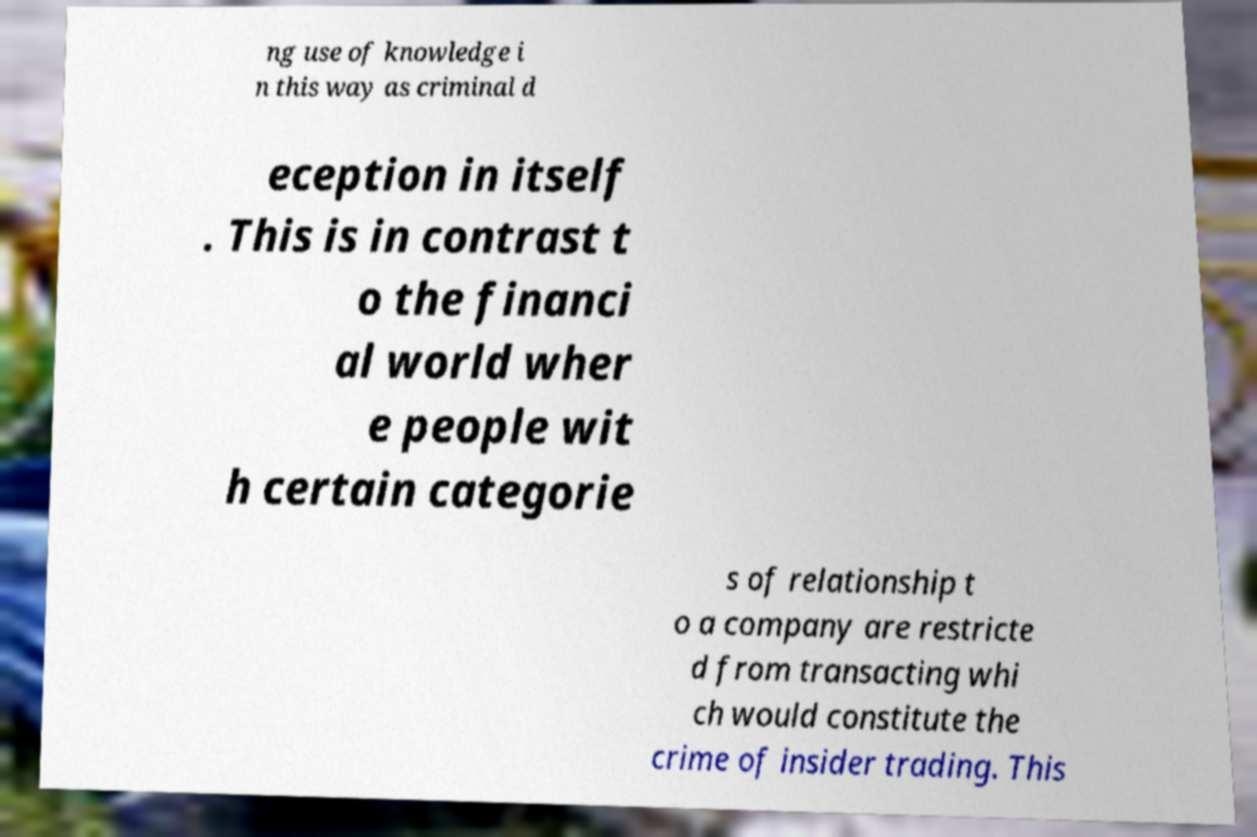For documentation purposes, I need the text within this image transcribed. Could you provide that? ng use of knowledge i n this way as criminal d eception in itself . This is in contrast t o the financi al world wher e people wit h certain categorie s of relationship t o a company are restricte d from transacting whi ch would constitute the crime of insider trading. This 